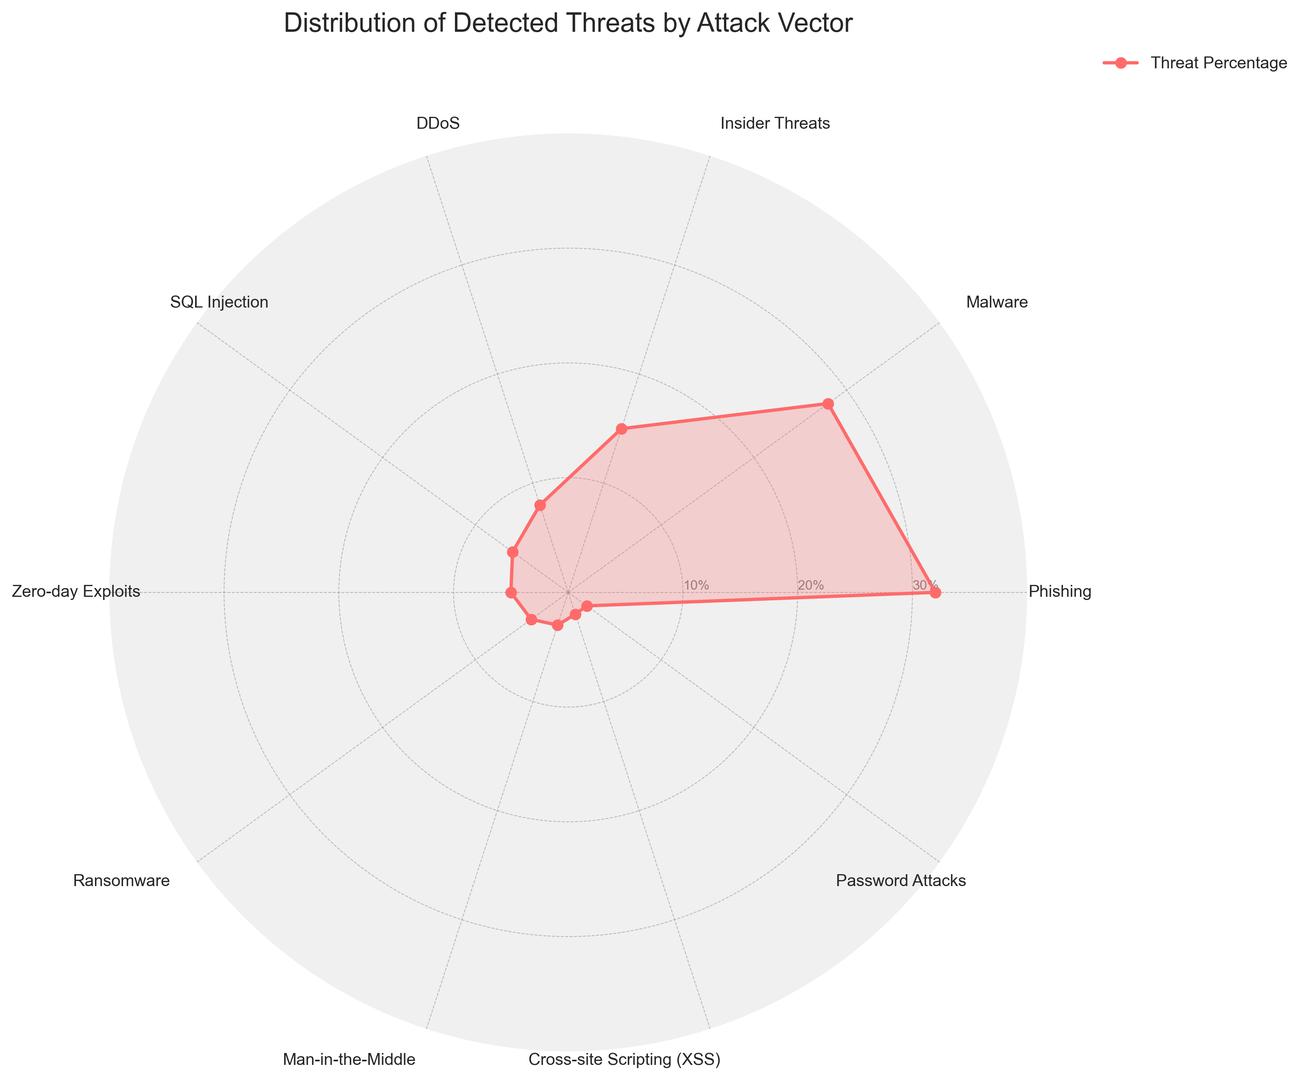Which attack vector has the highest detected threat percentage? By looking at the chart, the category with the highest value is identified. In this case, the radar chart's angle and length show that Phishing has the longest extension.
Answer: Phishing Which attack vectors have the same detected threat percentages? To answer this, look for labels on the radar chart that have arcs of the same length. The chart shows that Cross-site Scripting (XSS) and Password Attacks both extend to 2%.
Answer: Cross-site Scripting (XSS), Password Attacks How much higher is the percentage of detected Phishing threats compared to DDoS threats? Locate the Phishing percentage (32%) and DDoS percentage (8%) on the radar chart and subtract the lower value from the higher one: 32% - 8% = 24%.
Answer: 24% What is the total percentage of detected threats from Phishing, Malware, and Insider Threats combined? Add the percentages of the three attack vectors: Phishing (32%), Malware (28%), and Insider Threats (15%): 32% + 28% + 15% = 75%.
Answer: 75% Which attack vector has the lowest detected threat percentage? Identify the category with the smallest arc on the radar chart. The shortest length corresponds to Password Attacks and Cross-site Scripting (XSS), both with 2%.
Answer: Password Attacks, Cross-site Scripting (XSS) What is the difference in the detected threat percentage between Zero-Day Exploits and Ransomware? Find the percentages for Zero-Day Exploits (5%) and Ransomware (4%) and compute the difference: 5% - 4% = 1%.
Answer: 1% How do the percentages of Zero-Day Exploits and Man-in-the-Middle compare? Compare the percentages for Zero-Day Exploits (5%) and Man-in-the-Middle (3%) visually: Zero-Day Exploits' value is greater.
Answer: Zero-day Exploits is greater What is the average percentage of detected threats for the categories Phishing, DDoS, and SQL Injection? Sum the percentages for Phishing (32%), DDoS (8%), and SQL Injection (6%) and then divide by the number of categories: (32% + 8% + 6%) / 3 = 15.33%.
Answer: 15.33% Which attack vector is depicted in red color at the highest radial position? Examine the color and position presented in the chart. The red-colored chart’s peak corresponds to Phishing.
Answer: Phishing 